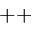Convert formula to latex. <formula><loc_0><loc_0><loc_500><loc_500>^ { + + }</formula> 